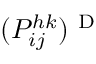<formula> <loc_0><loc_0><loc_500><loc_500>( P _ { i j } ^ { h k } ) ^ { D }</formula> 